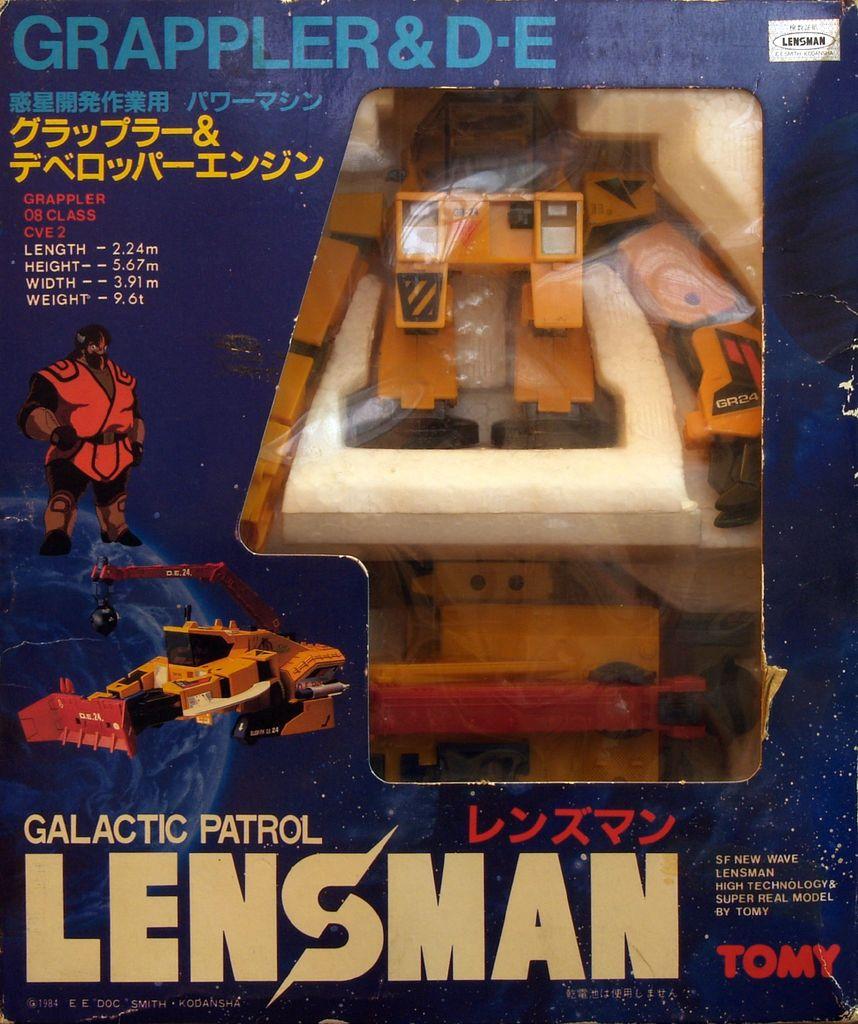Which company name is in the bottom right corner?
Provide a succinct answer. Tomy. 